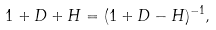Convert formula to latex. <formula><loc_0><loc_0><loc_500><loc_500>1 + D + H = ( 1 + D - H ) ^ { - 1 } ,</formula> 